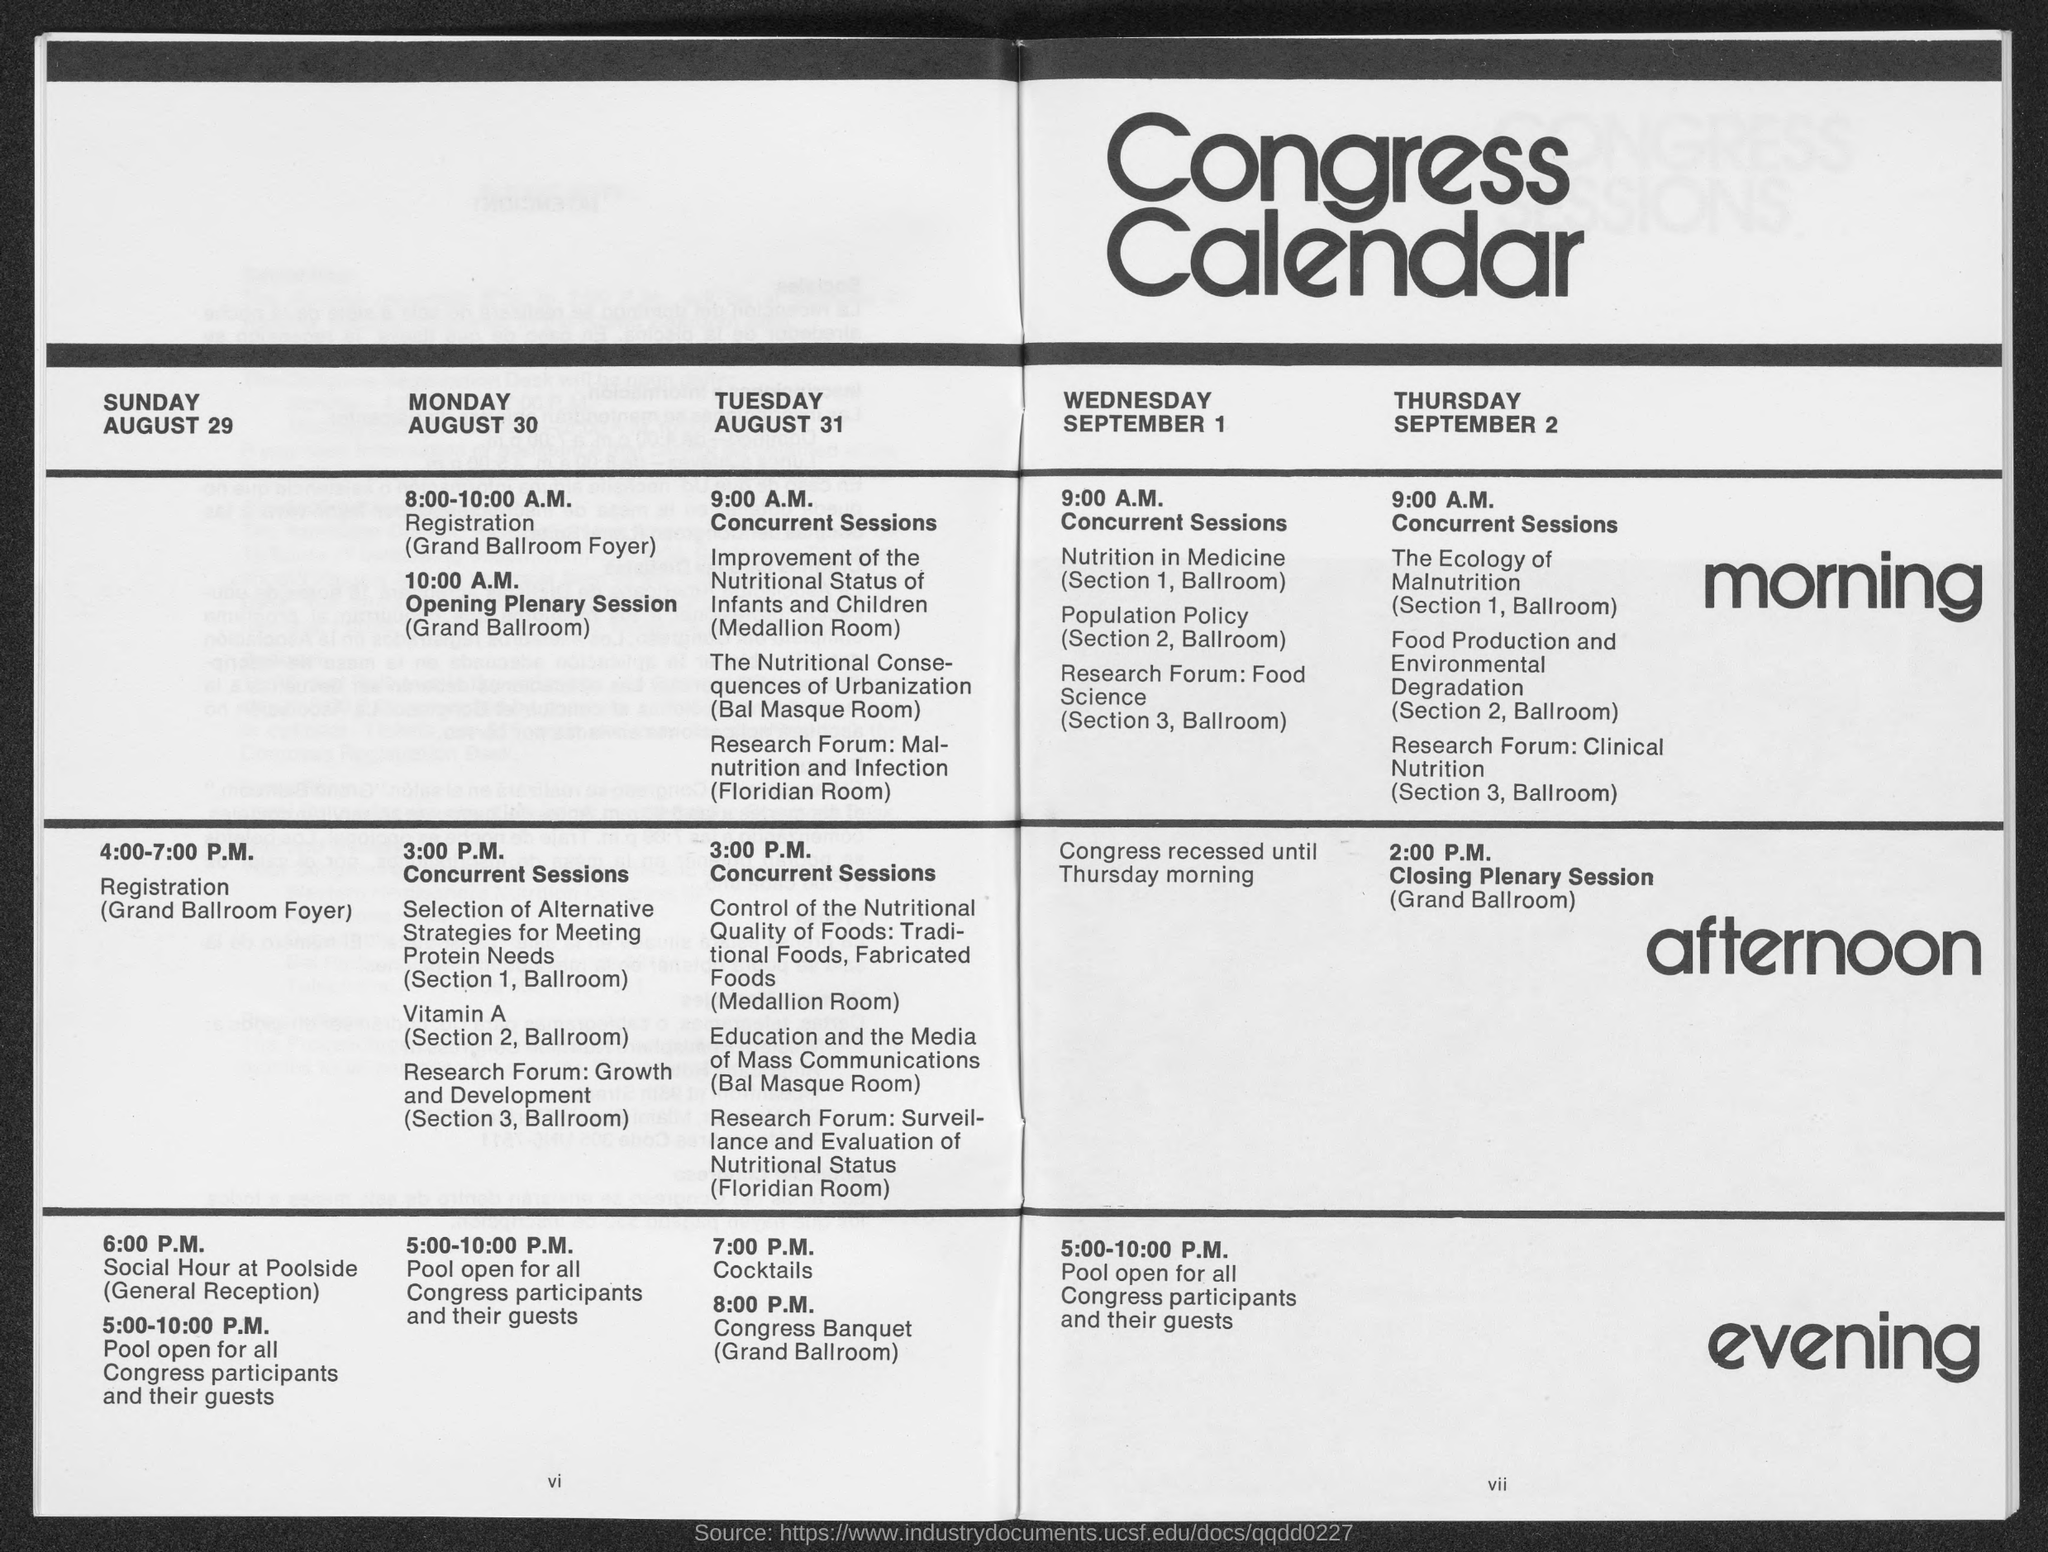At which time, does the registration starts on Monday ?
Ensure brevity in your answer.  8:00-10:00 A.M. At which time, does the registration starts on Sunday ?
Your answer should be compact. 4.00-7.00 P.M. When is the 'Closing Plenary Session' on Thursday?
Your answer should be very brief. 2.00 P.M. What is the first date shown in the Congress calendar ?
Your answer should be very brief. AUGUST 29. Which day is August 29 according to Congress Calendar?
Offer a very short reply. SUNDAY. When is the cocktail time on Tuesday ?
Give a very brief answer. 7.00 P.M. When is the concurrent sessions conducted on Thursday ?
Provide a succinct answer. 9:00 A.M. Which day is August 30 according to Congress Calendar ?
Offer a very short reply. Monday. 